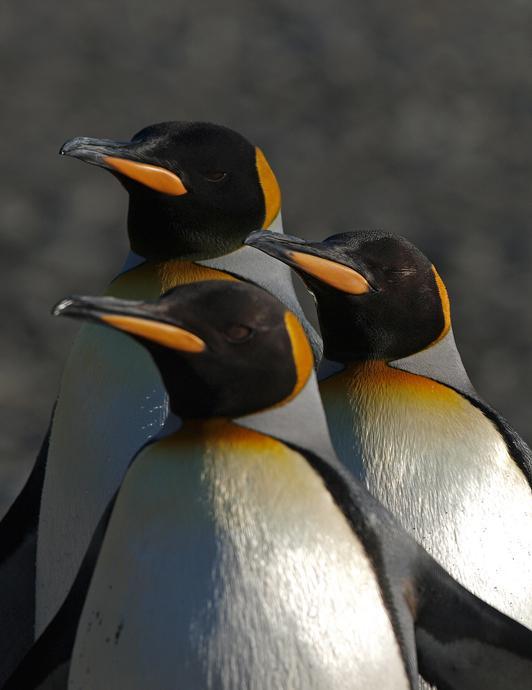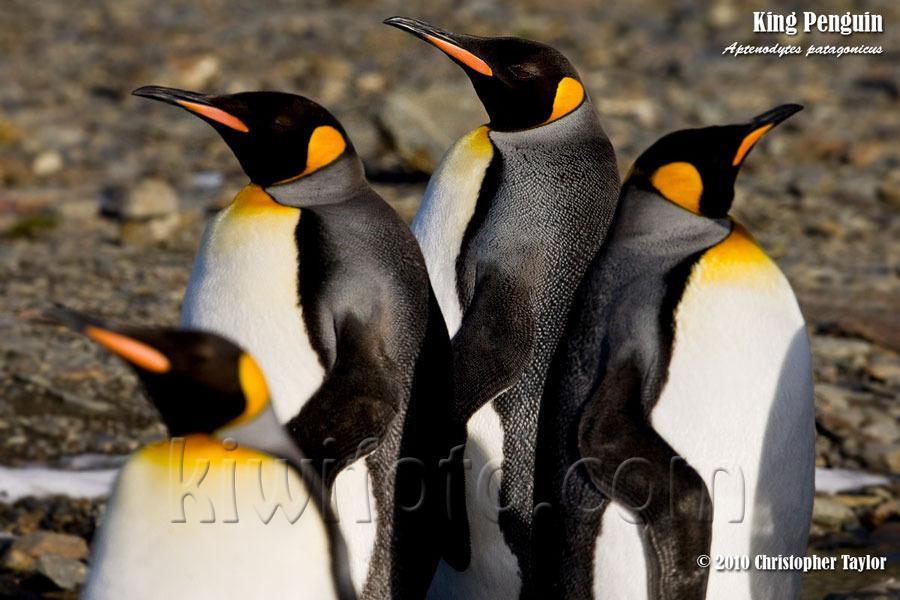The first image is the image on the left, the second image is the image on the right. Analyze the images presented: Is the assertion "One penguin is touching another penguins beak with its beak." valid? Answer yes or no. No. The first image is the image on the left, the second image is the image on the right. Evaluate the accuracy of this statement regarding the images: "There are two penguins facing the same direction in the left image.". Is it true? Answer yes or no. No. 